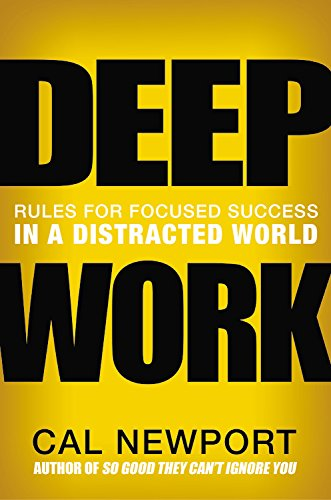Is this book related to Computers & Technology? While 'Deep Work' is not directly focused on Computers & Technology, it critically addresses how our digital environment can be structured to enhance focus and minimize technological distractions. 